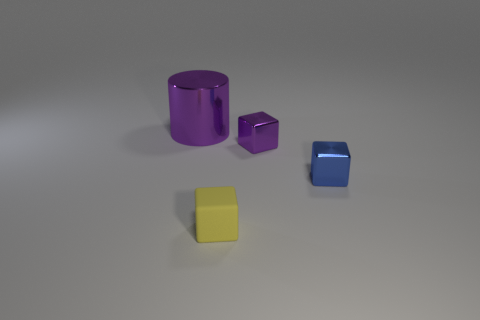Add 2 large green rubber cylinders. How many objects exist? 6 Subtract all cylinders. How many objects are left? 3 Subtract all small purple things. Subtract all tiny cyan rubber balls. How many objects are left? 3 Add 3 metallic objects. How many metallic objects are left? 6 Add 1 large metallic cylinders. How many large metallic cylinders exist? 2 Subtract 0 cyan cubes. How many objects are left? 4 